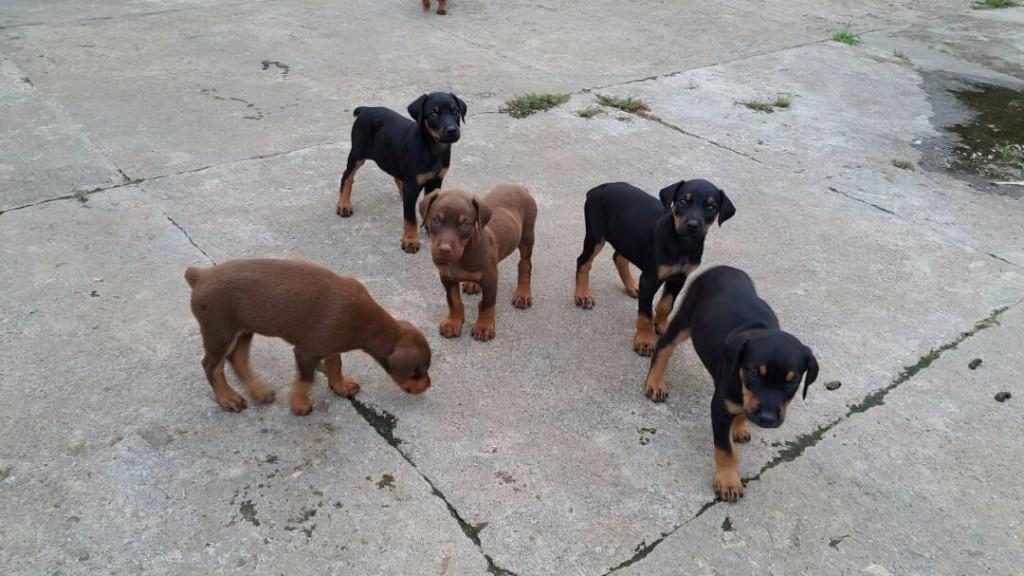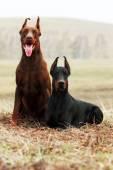The first image is the image on the left, the second image is the image on the right. For the images displayed, is the sentence "Two doberman with erect, pointy ears are facing forward and posed side-by-side in the right image." factually correct? Answer yes or no. Yes. The first image is the image on the left, the second image is the image on the right. For the images displayed, is the sentence "Two dogs are sitting in the grass in the image on the right." factually correct? Answer yes or no. Yes. 